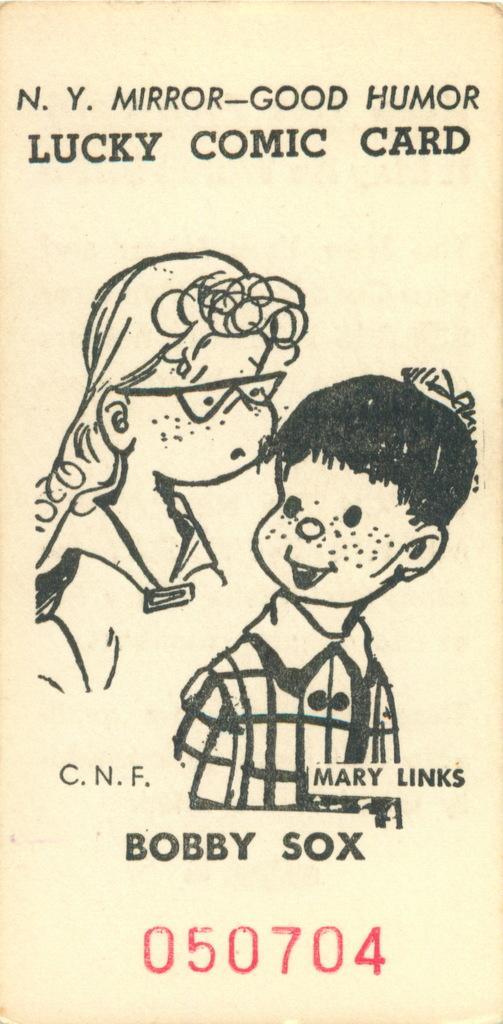Describe this image in one or two sentences. In this picture we can see the drawings of two people, words and numbers on the paper. 